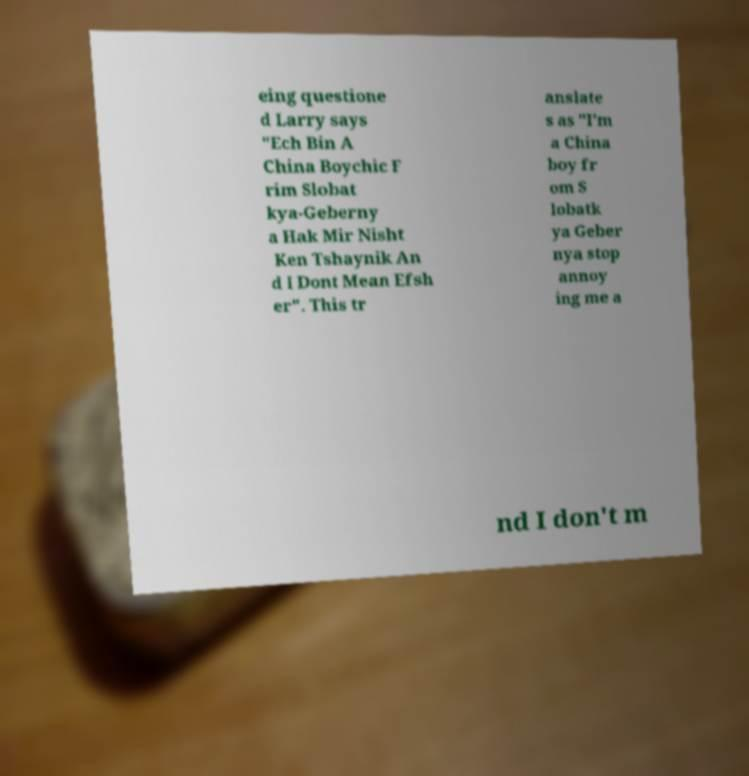Please identify and transcribe the text found in this image. eing questione d Larry says "Ech Bin A China Boychic F rim Slobat kya-Geberny a Hak Mir Nisht Ken Tshaynik An d I Dont Mean Efsh er". This tr anslate s as "I'm a China boy fr om S lobatk ya Geber nya stop annoy ing me a nd I don't m 